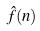Convert formula to latex. <formula><loc_0><loc_0><loc_500><loc_500>\hat { f } ( n )</formula> 